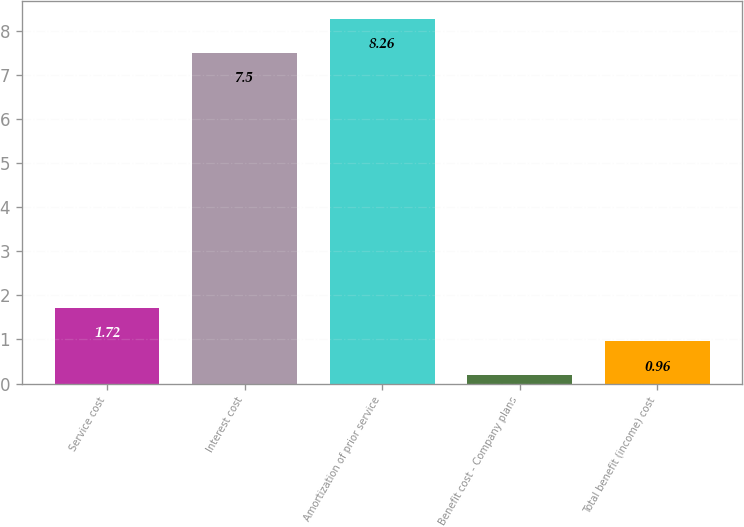Convert chart to OTSL. <chart><loc_0><loc_0><loc_500><loc_500><bar_chart><fcel>Service cost<fcel>Interest cost<fcel>Amortization of prior service<fcel>Benefit cost - Company plans<fcel>Total benefit (income) cost<nl><fcel>1.72<fcel>7.5<fcel>8.26<fcel>0.2<fcel>0.96<nl></chart> 